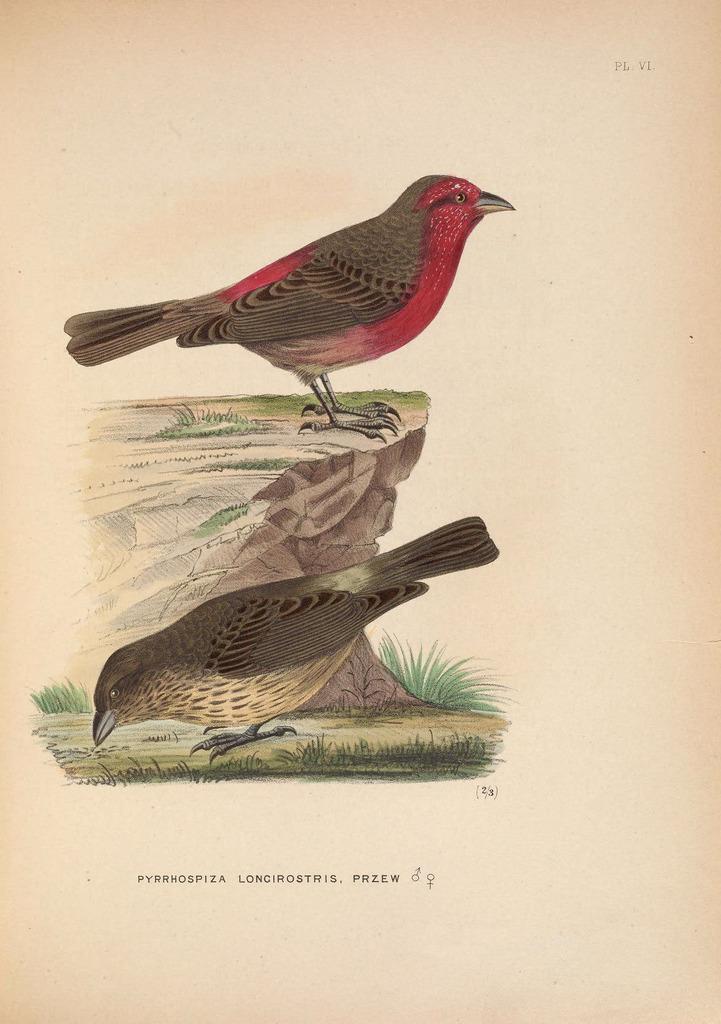How would you summarize this image in a sentence or two? In this image we can see drawing of two birds. One bird is on the wall and another bird is on the ground. At the bottom something is written. 